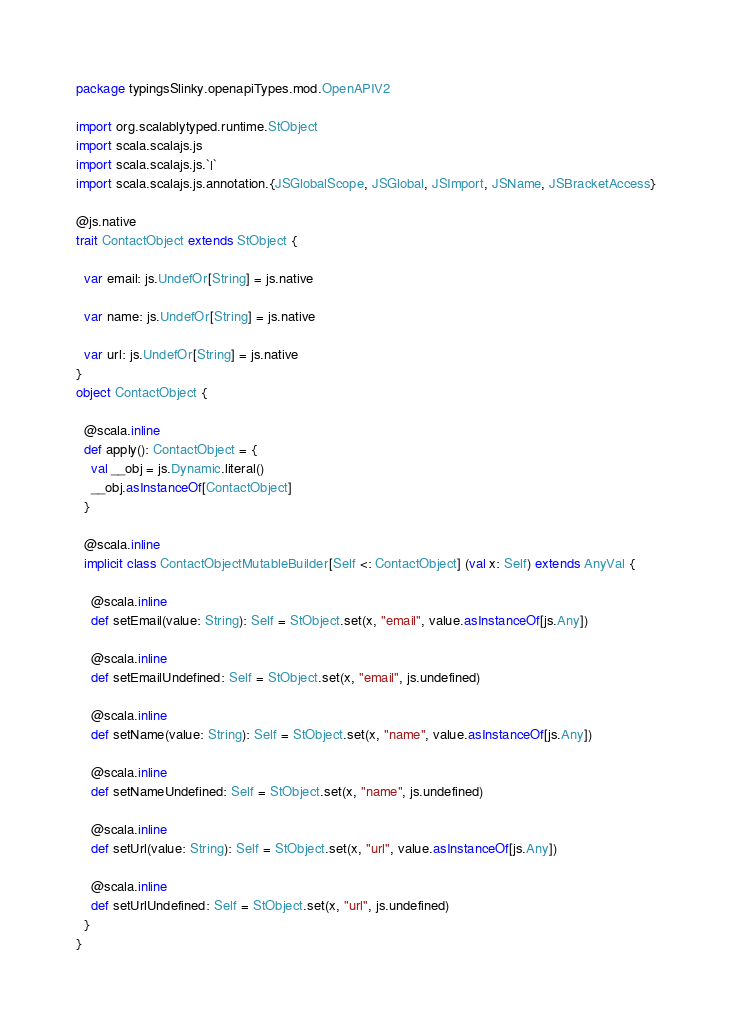<code> <loc_0><loc_0><loc_500><loc_500><_Scala_>package typingsSlinky.openapiTypes.mod.OpenAPIV2

import org.scalablytyped.runtime.StObject
import scala.scalajs.js
import scala.scalajs.js.`|`
import scala.scalajs.js.annotation.{JSGlobalScope, JSGlobal, JSImport, JSName, JSBracketAccess}

@js.native
trait ContactObject extends StObject {
  
  var email: js.UndefOr[String] = js.native
  
  var name: js.UndefOr[String] = js.native
  
  var url: js.UndefOr[String] = js.native
}
object ContactObject {
  
  @scala.inline
  def apply(): ContactObject = {
    val __obj = js.Dynamic.literal()
    __obj.asInstanceOf[ContactObject]
  }
  
  @scala.inline
  implicit class ContactObjectMutableBuilder[Self <: ContactObject] (val x: Self) extends AnyVal {
    
    @scala.inline
    def setEmail(value: String): Self = StObject.set(x, "email", value.asInstanceOf[js.Any])
    
    @scala.inline
    def setEmailUndefined: Self = StObject.set(x, "email", js.undefined)
    
    @scala.inline
    def setName(value: String): Self = StObject.set(x, "name", value.asInstanceOf[js.Any])
    
    @scala.inline
    def setNameUndefined: Self = StObject.set(x, "name", js.undefined)
    
    @scala.inline
    def setUrl(value: String): Self = StObject.set(x, "url", value.asInstanceOf[js.Any])
    
    @scala.inline
    def setUrlUndefined: Self = StObject.set(x, "url", js.undefined)
  }
}
</code> 